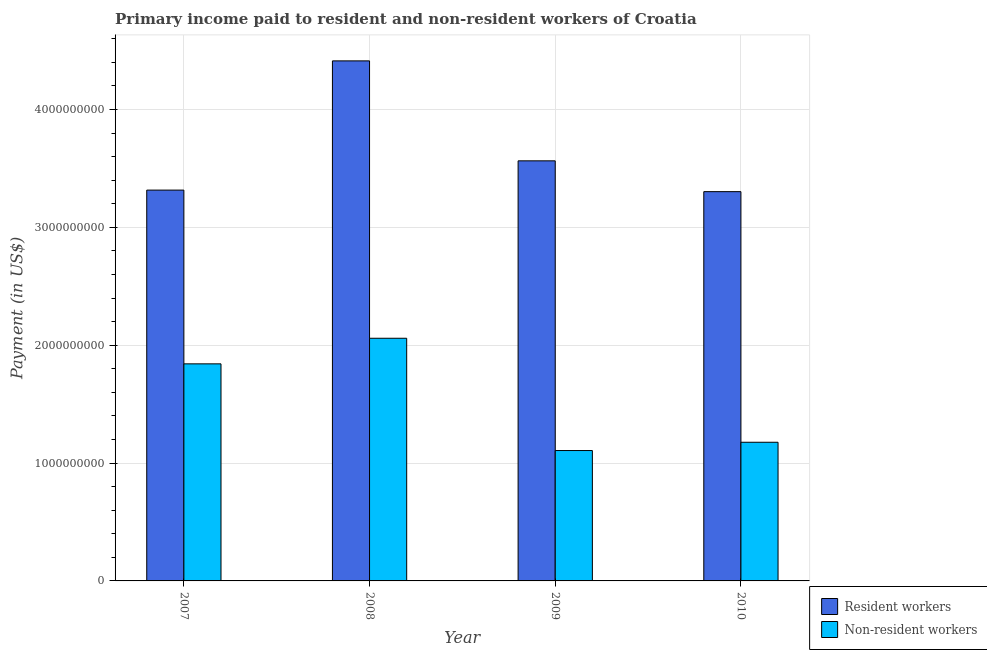How many different coloured bars are there?
Make the answer very short. 2. How many groups of bars are there?
Give a very brief answer. 4. How many bars are there on the 1st tick from the right?
Offer a very short reply. 2. What is the label of the 4th group of bars from the left?
Your response must be concise. 2010. In how many cases, is the number of bars for a given year not equal to the number of legend labels?
Your response must be concise. 0. What is the payment made to resident workers in 2009?
Provide a short and direct response. 3.56e+09. Across all years, what is the maximum payment made to non-resident workers?
Your response must be concise. 2.06e+09. Across all years, what is the minimum payment made to non-resident workers?
Provide a short and direct response. 1.11e+09. In which year was the payment made to non-resident workers maximum?
Give a very brief answer. 2008. What is the total payment made to resident workers in the graph?
Offer a very short reply. 1.46e+1. What is the difference between the payment made to resident workers in 2008 and that in 2009?
Give a very brief answer. 8.48e+08. What is the difference between the payment made to resident workers in 2008 and the payment made to non-resident workers in 2010?
Provide a succinct answer. 1.11e+09. What is the average payment made to resident workers per year?
Give a very brief answer. 3.65e+09. In how many years, is the payment made to resident workers greater than 2400000000 US$?
Offer a terse response. 4. What is the ratio of the payment made to resident workers in 2008 to that in 2009?
Your answer should be compact. 1.24. Is the payment made to resident workers in 2007 less than that in 2010?
Ensure brevity in your answer.  No. Is the difference between the payment made to non-resident workers in 2009 and 2010 greater than the difference between the payment made to resident workers in 2009 and 2010?
Make the answer very short. No. What is the difference between the highest and the second highest payment made to non-resident workers?
Keep it short and to the point. 2.17e+08. What is the difference between the highest and the lowest payment made to resident workers?
Give a very brief answer. 1.11e+09. In how many years, is the payment made to resident workers greater than the average payment made to resident workers taken over all years?
Ensure brevity in your answer.  1. What does the 2nd bar from the left in 2009 represents?
Provide a succinct answer. Non-resident workers. What does the 2nd bar from the right in 2008 represents?
Ensure brevity in your answer.  Resident workers. What is the difference between two consecutive major ticks on the Y-axis?
Provide a short and direct response. 1.00e+09. Does the graph contain grids?
Offer a very short reply. Yes. What is the title of the graph?
Keep it short and to the point. Primary income paid to resident and non-resident workers of Croatia. What is the label or title of the X-axis?
Offer a very short reply. Year. What is the label or title of the Y-axis?
Offer a very short reply. Payment (in US$). What is the Payment (in US$) of Resident workers in 2007?
Make the answer very short. 3.32e+09. What is the Payment (in US$) of Non-resident workers in 2007?
Make the answer very short. 1.84e+09. What is the Payment (in US$) of Resident workers in 2008?
Make the answer very short. 4.41e+09. What is the Payment (in US$) in Non-resident workers in 2008?
Keep it short and to the point. 2.06e+09. What is the Payment (in US$) of Resident workers in 2009?
Give a very brief answer. 3.56e+09. What is the Payment (in US$) of Non-resident workers in 2009?
Offer a very short reply. 1.11e+09. What is the Payment (in US$) of Resident workers in 2010?
Your answer should be very brief. 3.30e+09. What is the Payment (in US$) of Non-resident workers in 2010?
Ensure brevity in your answer.  1.18e+09. Across all years, what is the maximum Payment (in US$) of Resident workers?
Keep it short and to the point. 4.41e+09. Across all years, what is the maximum Payment (in US$) in Non-resident workers?
Your response must be concise. 2.06e+09. Across all years, what is the minimum Payment (in US$) in Resident workers?
Offer a very short reply. 3.30e+09. Across all years, what is the minimum Payment (in US$) of Non-resident workers?
Make the answer very short. 1.11e+09. What is the total Payment (in US$) in Resident workers in the graph?
Ensure brevity in your answer.  1.46e+1. What is the total Payment (in US$) of Non-resident workers in the graph?
Provide a succinct answer. 6.18e+09. What is the difference between the Payment (in US$) in Resident workers in 2007 and that in 2008?
Keep it short and to the point. -1.10e+09. What is the difference between the Payment (in US$) in Non-resident workers in 2007 and that in 2008?
Provide a succinct answer. -2.17e+08. What is the difference between the Payment (in US$) in Resident workers in 2007 and that in 2009?
Your response must be concise. -2.48e+08. What is the difference between the Payment (in US$) of Non-resident workers in 2007 and that in 2009?
Your answer should be compact. 7.36e+08. What is the difference between the Payment (in US$) of Resident workers in 2007 and that in 2010?
Offer a very short reply. 1.30e+07. What is the difference between the Payment (in US$) of Non-resident workers in 2007 and that in 2010?
Keep it short and to the point. 6.65e+08. What is the difference between the Payment (in US$) of Resident workers in 2008 and that in 2009?
Offer a terse response. 8.48e+08. What is the difference between the Payment (in US$) in Non-resident workers in 2008 and that in 2009?
Keep it short and to the point. 9.53e+08. What is the difference between the Payment (in US$) in Resident workers in 2008 and that in 2010?
Your answer should be very brief. 1.11e+09. What is the difference between the Payment (in US$) in Non-resident workers in 2008 and that in 2010?
Provide a succinct answer. 8.82e+08. What is the difference between the Payment (in US$) in Resident workers in 2009 and that in 2010?
Provide a short and direct response. 2.61e+08. What is the difference between the Payment (in US$) of Non-resident workers in 2009 and that in 2010?
Give a very brief answer. -7.03e+07. What is the difference between the Payment (in US$) of Resident workers in 2007 and the Payment (in US$) of Non-resident workers in 2008?
Provide a short and direct response. 1.26e+09. What is the difference between the Payment (in US$) in Resident workers in 2007 and the Payment (in US$) in Non-resident workers in 2009?
Your answer should be very brief. 2.21e+09. What is the difference between the Payment (in US$) of Resident workers in 2007 and the Payment (in US$) of Non-resident workers in 2010?
Offer a very short reply. 2.14e+09. What is the difference between the Payment (in US$) of Resident workers in 2008 and the Payment (in US$) of Non-resident workers in 2009?
Offer a very short reply. 3.31e+09. What is the difference between the Payment (in US$) of Resident workers in 2008 and the Payment (in US$) of Non-resident workers in 2010?
Your answer should be compact. 3.24e+09. What is the difference between the Payment (in US$) of Resident workers in 2009 and the Payment (in US$) of Non-resident workers in 2010?
Your response must be concise. 2.39e+09. What is the average Payment (in US$) in Resident workers per year?
Offer a very short reply. 3.65e+09. What is the average Payment (in US$) in Non-resident workers per year?
Offer a very short reply. 1.55e+09. In the year 2007, what is the difference between the Payment (in US$) in Resident workers and Payment (in US$) in Non-resident workers?
Provide a succinct answer. 1.47e+09. In the year 2008, what is the difference between the Payment (in US$) of Resident workers and Payment (in US$) of Non-resident workers?
Give a very brief answer. 2.35e+09. In the year 2009, what is the difference between the Payment (in US$) of Resident workers and Payment (in US$) of Non-resident workers?
Provide a succinct answer. 2.46e+09. In the year 2010, what is the difference between the Payment (in US$) of Resident workers and Payment (in US$) of Non-resident workers?
Give a very brief answer. 2.13e+09. What is the ratio of the Payment (in US$) in Resident workers in 2007 to that in 2008?
Ensure brevity in your answer.  0.75. What is the ratio of the Payment (in US$) in Non-resident workers in 2007 to that in 2008?
Provide a short and direct response. 0.89. What is the ratio of the Payment (in US$) in Resident workers in 2007 to that in 2009?
Keep it short and to the point. 0.93. What is the ratio of the Payment (in US$) in Non-resident workers in 2007 to that in 2009?
Your response must be concise. 1.66. What is the ratio of the Payment (in US$) in Resident workers in 2007 to that in 2010?
Offer a terse response. 1. What is the ratio of the Payment (in US$) of Non-resident workers in 2007 to that in 2010?
Your response must be concise. 1.57. What is the ratio of the Payment (in US$) in Resident workers in 2008 to that in 2009?
Provide a short and direct response. 1.24. What is the ratio of the Payment (in US$) of Non-resident workers in 2008 to that in 2009?
Provide a succinct answer. 1.86. What is the ratio of the Payment (in US$) in Resident workers in 2008 to that in 2010?
Provide a short and direct response. 1.34. What is the ratio of the Payment (in US$) of Resident workers in 2009 to that in 2010?
Provide a succinct answer. 1.08. What is the ratio of the Payment (in US$) of Non-resident workers in 2009 to that in 2010?
Make the answer very short. 0.94. What is the difference between the highest and the second highest Payment (in US$) in Resident workers?
Your response must be concise. 8.48e+08. What is the difference between the highest and the second highest Payment (in US$) of Non-resident workers?
Your response must be concise. 2.17e+08. What is the difference between the highest and the lowest Payment (in US$) of Resident workers?
Your response must be concise. 1.11e+09. What is the difference between the highest and the lowest Payment (in US$) of Non-resident workers?
Your response must be concise. 9.53e+08. 